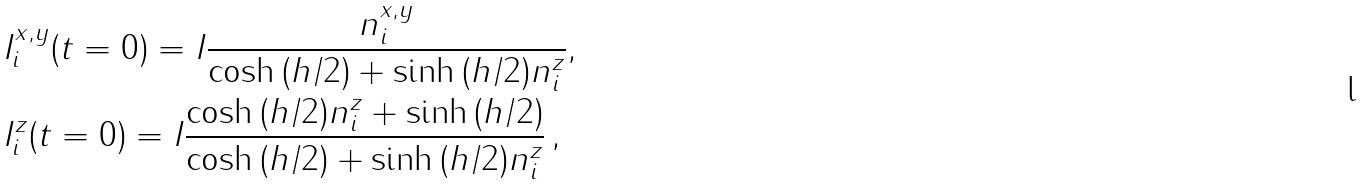<formula> <loc_0><loc_0><loc_500><loc_500>& I ^ { x , y } _ { i } ( t = 0 ) = I \frac { n _ { i } ^ { x , y } } { \cosh { ( h / 2 ) } + \sinh { ( h / 2 ) } n _ { i } ^ { z } } , \\ & I ^ { z } _ { i } ( t = 0 ) = I \frac { \cosh { ( h / 2 ) } n _ { i } ^ { z } + \sinh { ( h / 2 ) } } { \cosh { ( h / 2 ) } + \sinh { ( h / 2 ) } n _ { i } ^ { z } } \, ,</formula> 